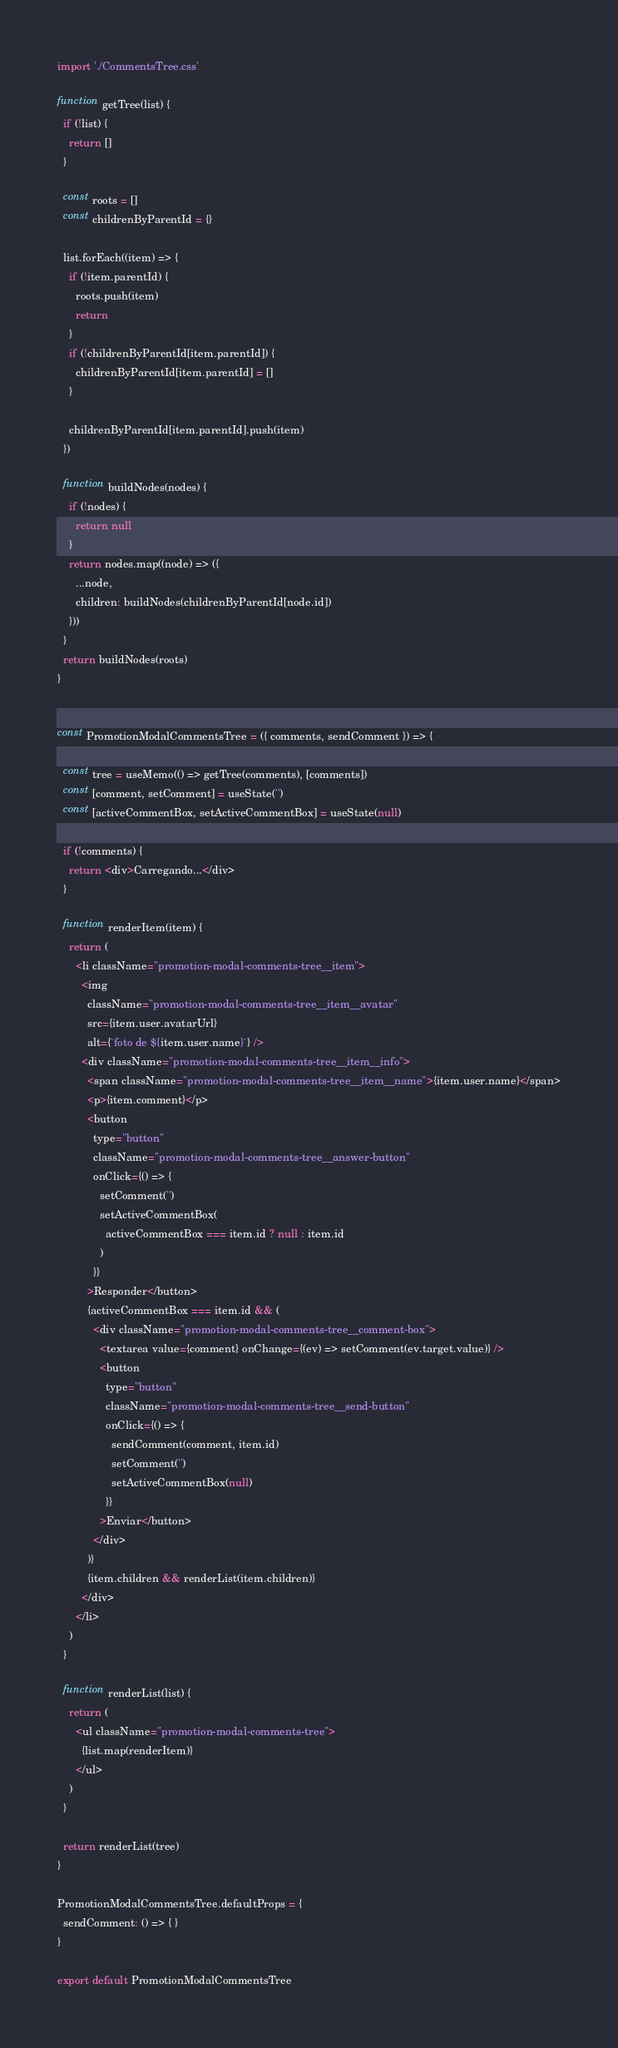Convert code to text. <code><loc_0><loc_0><loc_500><loc_500><_JavaScript_>import './CommentsTree.css'

function getTree(list) {
  if (!list) {
    return []
  }

  const roots = []
  const childrenByParentId = {}

  list.forEach((item) => {
    if (!item.parentId) {
      roots.push(item)
      return
    }
    if (!childrenByParentId[item.parentId]) {
      childrenByParentId[item.parentId] = []
    }

    childrenByParentId[item.parentId].push(item)
  })

  function buildNodes(nodes) {
    if (!nodes) {
      return null
    }
    return nodes.map((node) => ({
      ...node,
      children: buildNodes(childrenByParentId[node.id])
    }))
  }
  return buildNodes(roots)
}


const PromotionModalCommentsTree = ({ comments, sendComment }) => {

  const tree = useMemo(() => getTree(comments), [comments])
  const [comment, setComment] = useState('')
  const [activeCommentBox, setActiveCommentBox] = useState(null)

  if (!comments) {
    return <div>Carregando...</div>
  }

  function renderItem(item) {
    return (
      <li className="promotion-modal-comments-tree__item">
        <img
          className="promotion-modal-comments-tree__item__avatar"
          src={item.user.avatarUrl}
          alt={`foto de ${item.user.name}`} />
        <div className="promotion-modal-comments-tree__item__info">
          <span className="promotion-modal-comments-tree__item__name">{item.user.name}</span>
          <p>{item.comment}</p>
          <button
            type="button"
            className="promotion-modal-comments-tree__answer-button"
            onClick={() => {
              setComment('')
              setActiveCommentBox(
                activeCommentBox === item.id ? null : item.id
              )
            }}
          >Responder</button>
          {activeCommentBox === item.id && (
            <div className="promotion-modal-comments-tree__comment-box">
              <textarea value={comment} onChange={(ev) => setComment(ev.target.value)} />
              <button
                type="button"
                className="promotion-modal-comments-tree__send-button"
                onClick={() => {
                  sendComment(comment, item.id)
                  setComment('')
                  setActiveCommentBox(null)
                }}
              >Enviar</button>
            </div>
          )}
          {item.children && renderList(item.children)}
        </div>
      </li>
    )
  }

  function renderList(list) {
    return (
      <ul className="promotion-modal-comments-tree">
        {list.map(renderItem)}
      </ul>
    )
  }

  return renderList(tree)
}

PromotionModalCommentsTree.defaultProps = {
  sendComment: () => { }
}

export default PromotionModalCommentsTree</code> 